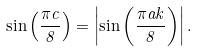Convert formula to latex. <formula><loc_0><loc_0><loc_500><loc_500>\sin \left ( \frac { \pi c } { 8 } \right ) = \left | \sin \left ( \frac { \pi a k } { 8 } \right ) \right | .</formula> 